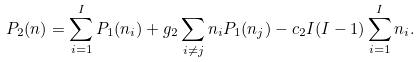Convert formula to latex. <formula><loc_0><loc_0><loc_500><loc_500>P _ { 2 } ( n ) = \sum _ { i = 1 } ^ { I } P _ { 1 } ( n _ { i } ) + g _ { 2 } \sum _ { i \neq j } n _ { i } P _ { 1 } ( n _ { j } ) - c _ { 2 } I ( I - 1 ) \sum _ { i = 1 } ^ { I } n _ { i } .</formula> 